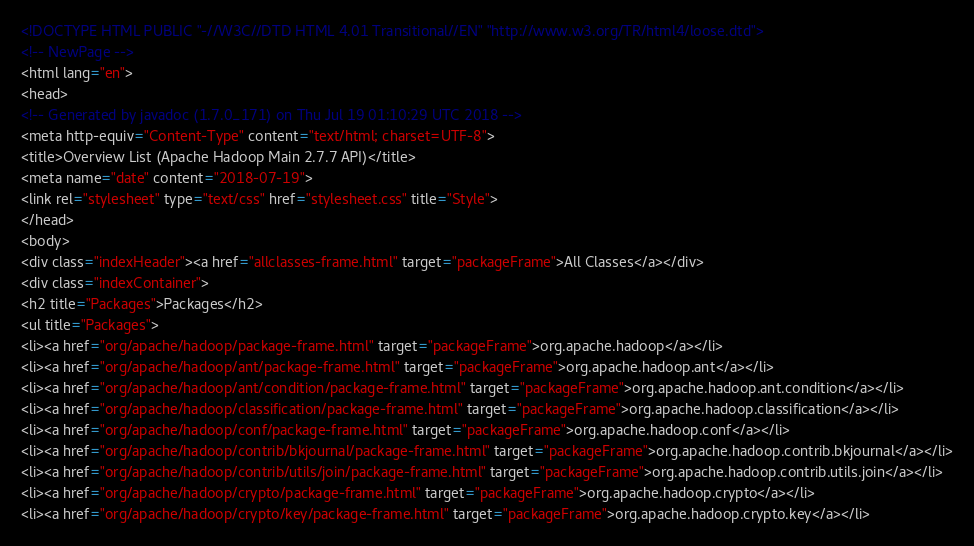<code> <loc_0><loc_0><loc_500><loc_500><_HTML_><!DOCTYPE HTML PUBLIC "-//W3C//DTD HTML 4.01 Transitional//EN" "http://www.w3.org/TR/html4/loose.dtd">
<!-- NewPage -->
<html lang="en">
<head>
<!-- Generated by javadoc (1.7.0_171) on Thu Jul 19 01:10:29 UTC 2018 -->
<meta http-equiv="Content-Type" content="text/html; charset=UTF-8">
<title>Overview List (Apache Hadoop Main 2.7.7 API)</title>
<meta name="date" content="2018-07-19">
<link rel="stylesheet" type="text/css" href="stylesheet.css" title="Style">
</head>
<body>
<div class="indexHeader"><a href="allclasses-frame.html" target="packageFrame">All Classes</a></div>
<div class="indexContainer">
<h2 title="Packages">Packages</h2>
<ul title="Packages">
<li><a href="org/apache/hadoop/package-frame.html" target="packageFrame">org.apache.hadoop</a></li>
<li><a href="org/apache/hadoop/ant/package-frame.html" target="packageFrame">org.apache.hadoop.ant</a></li>
<li><a href="org/apache/hadoop/ant/condition/package-frame.html" target="packageFrame">org.apache.hadoop.ant.condition</a></li>
<li><a href="org/apache/hadoop/classification/package-frame.html" target="packageFrame">org.apache.hadoop.classification</a></li>
<li><a href="org/apache/hadoop/conf/package-frame.html" target="packageFrame">org.apache.hadoop.conf</a></li>
<li><a href="org/apache/hadoop/contrib/bkjournal/package-frame.html" target="packageFrame">org.apache.hadoop.contrib.bkjournal</a></li>
<li><a href="org/apache/hadoop/contrib/utils/join/package-frame.html" target="packageFrame">org.apache.hadoop.contrib.utils.join</a></li>
<li><a href="org/apache/hadoop/crypto/package-frame.html" target="packageFrame">org.apache.hadoop.crypto</a></li>
<li><a href="org/apache/hadoop/crypto/key/package-frame.html" target="packageFrame">org.apache.hadoop.crypto.key</a></li></code> 